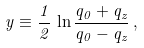<formula> <loc_0><loc_0><loc_500><loc_500>y \equiv \frac { 1 } { 2 } \, \ln \frac { q _ { 0 } + q _ { z } } { q _ { 0 } - q _ { z } } \, ,</formula> 